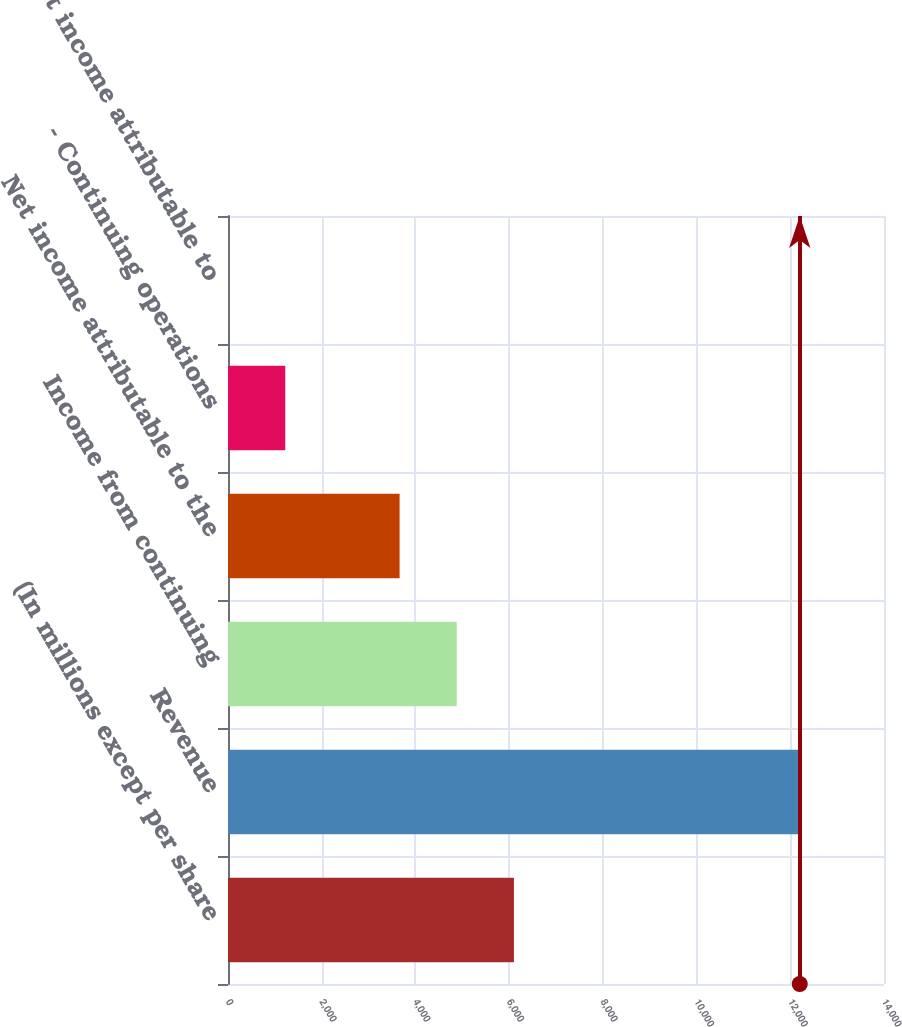Convert chart to OTSL. <chart><loc_0><loc_0><loc_500><loc_500><bar_chart><fcel>(In millions except per share<fcel>Revenue<fcel>Income from continuing<fcel>Net income attributable to the<fcel>- Continuing operations<fcel>- Net income attributable to<nl><fcel>6102.06<fcel>12202<fcel>4882.08<fcel>3662.1<fcel>1222.14<fcel>2.16<nl></chart> 